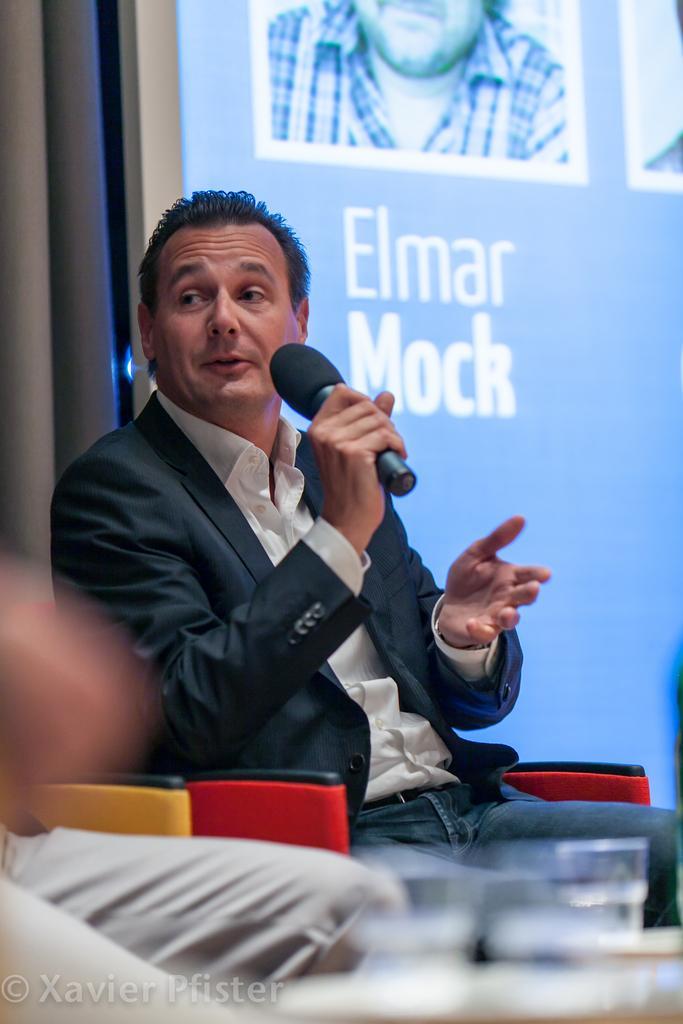In one or two sentences, can you explain what this image depicts? There is a man sitting holding a microphone in his hand and speaking behind him there is a screen. 